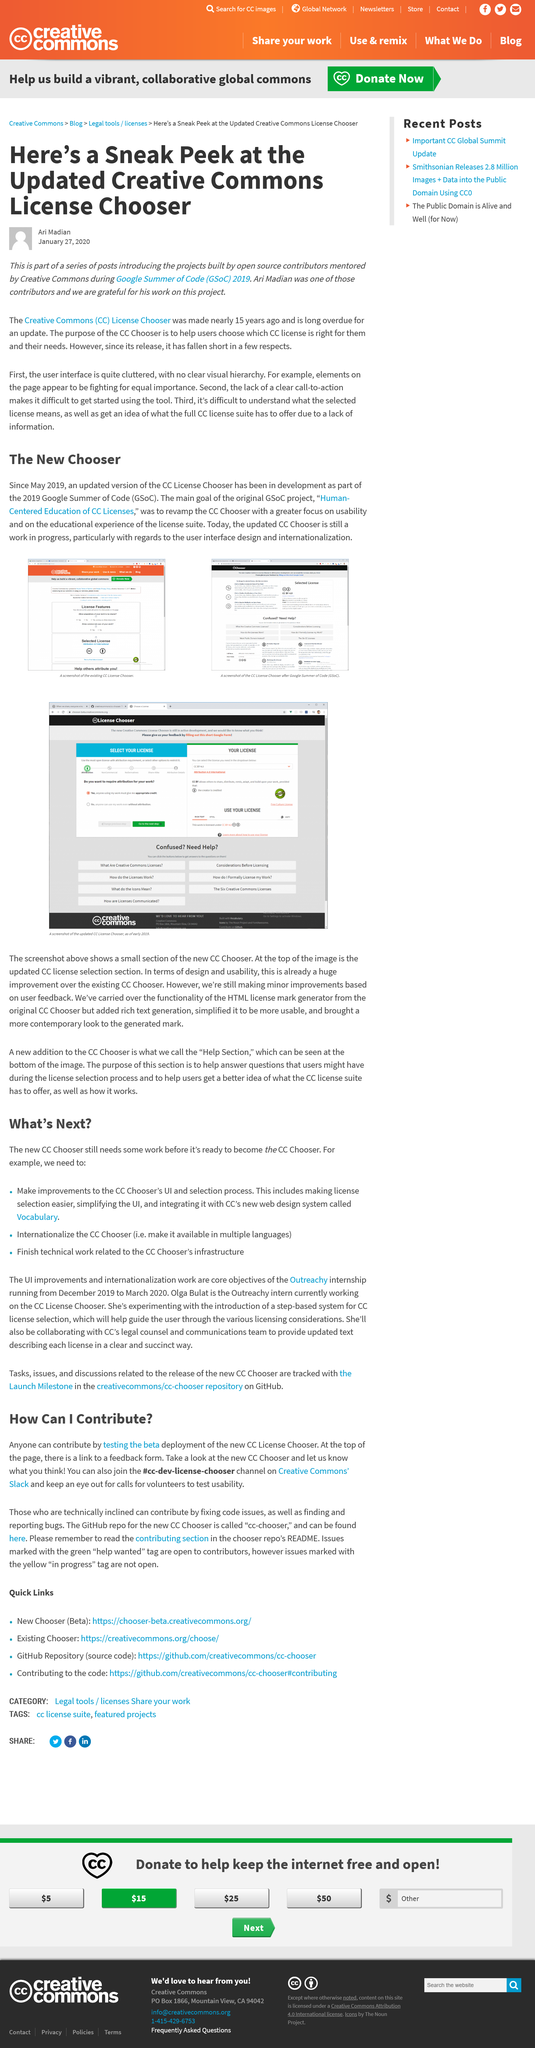List a handful of essential elements in this visual. This transcript was created on January 27, 2020. Technically inclined individuals can contribute to the development of the new CC Chooser by fixing code issues and finding and reporting bugs. It was created by Ari Madian. The Consumer Contract (CC) was created nearly 15 years ago. You can join the #cc-dev-license-chooser channel on the Creative Commons Slack platform to participate in discussions and choose a suitable license for your creative work. 